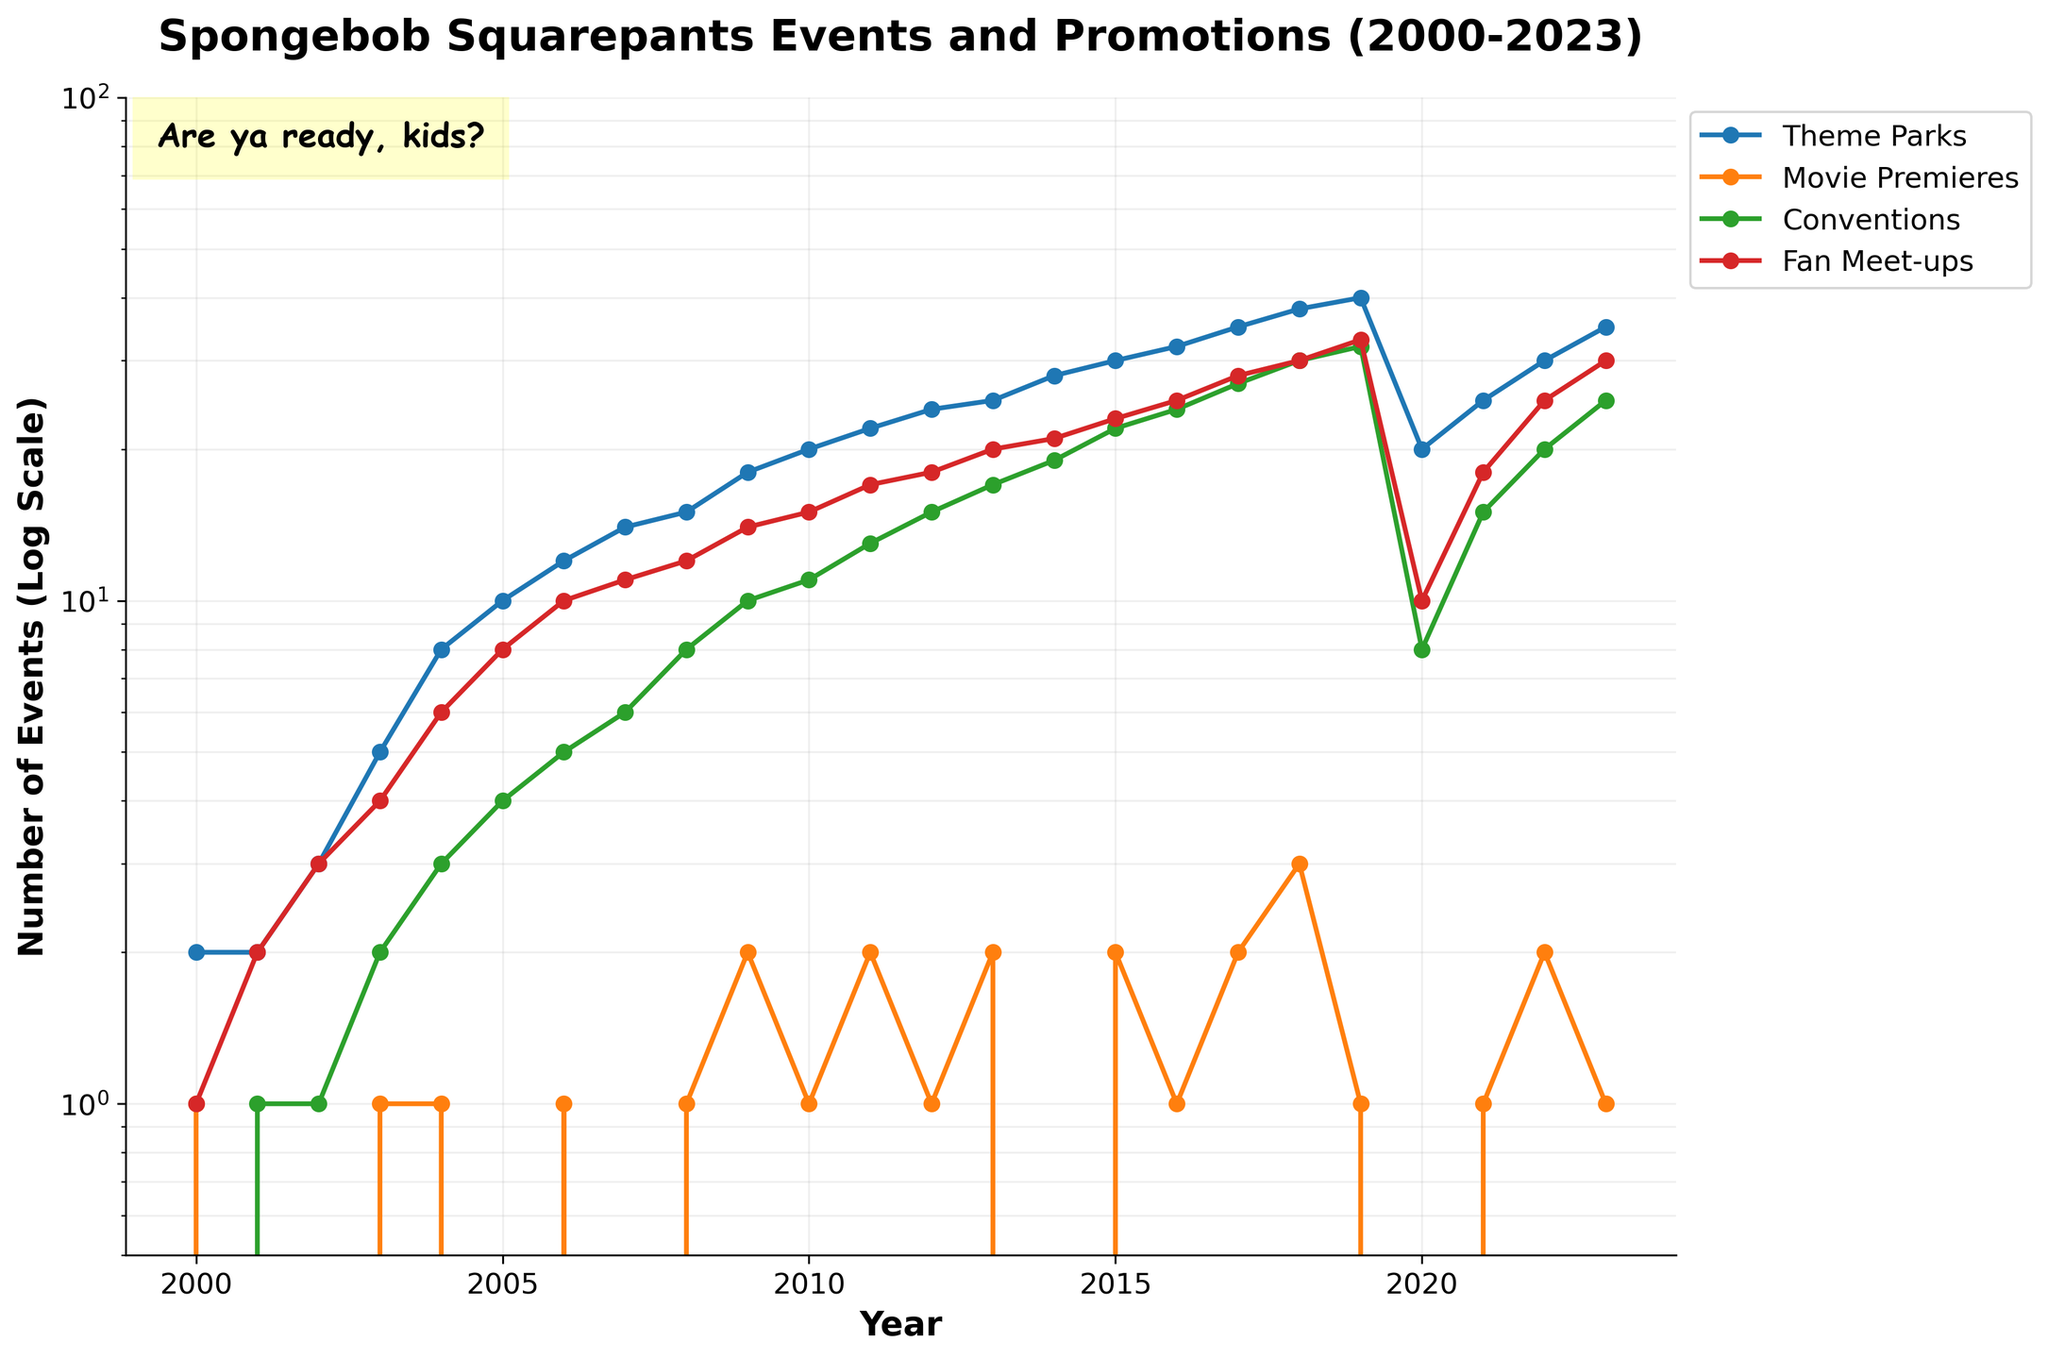What is the title of the line plot? The title is located at the top of the figure. It provides a concise description of the plotted data.
Answer: Spongebob Squarepants Events and Promotions (2000-2023) Which type of event had the largest number of events in 2023? Look at the figure for the data point in 2023 and compare the heights of the lines for each event type. The highest point among the lines will indicate the event with the largest number.
Answer: Theme Parks How many movie premieres were held in 2019? Locate the year 2019 on the x-axis and check the corresponding data point for the "Movie Premieres" line.
Answer: 1 Which event type had the lowest number of occurrences from 2000 to 2023? Observe the lines for all event types across the plotted years and identify the line that persists at the lowest levels throughout the timeline.
Answer: Conventions What was the peak number of fan meet-ups held in any year? Identify the highest point on the "Fan Meet-ups" line and check the corresponding value on the y-axis.
Answer: 33 What happened to the number of theme parks events in 2020 compared to 2019? Compare the data points for the years 2019 and 2020 on the "Theme Parks" line to see if the number increased, decreased, or remained the same.
Answer: Decreased During which year did conventions experience a significant drop, and what was the value before and after that drop? Track the "Conventions" line and find the year where there is a noticeable drop. Then note the y-axis values just before and after the drop.
Answer: 2020, from 32 to 8 Between which years did the number of movie premieres see the maximum fluctuation? Examine the "Movie Premieres" line to identify the two consecutive years with the largest difference in the number of events.
Answer: 2019 and 2020 What's the average annual growth rate of "Theme Parks" events from 2000 to 2018? Calculate the difference in the number of "Theme Parks" events between 2000 and 2018, then divide by the number of years (2018-2000) to find the average annual growth. ((38-2)/18)
Answer: 2 events per year What are the trends observed in the number of conventions and fan meet-ups events after 2020? Look at the lines for "Conventions" and "Fan Meet-ups" from 2020 onward and describe whether they are increasing, decreasing, or stable over these years.
Answer: Increasing 